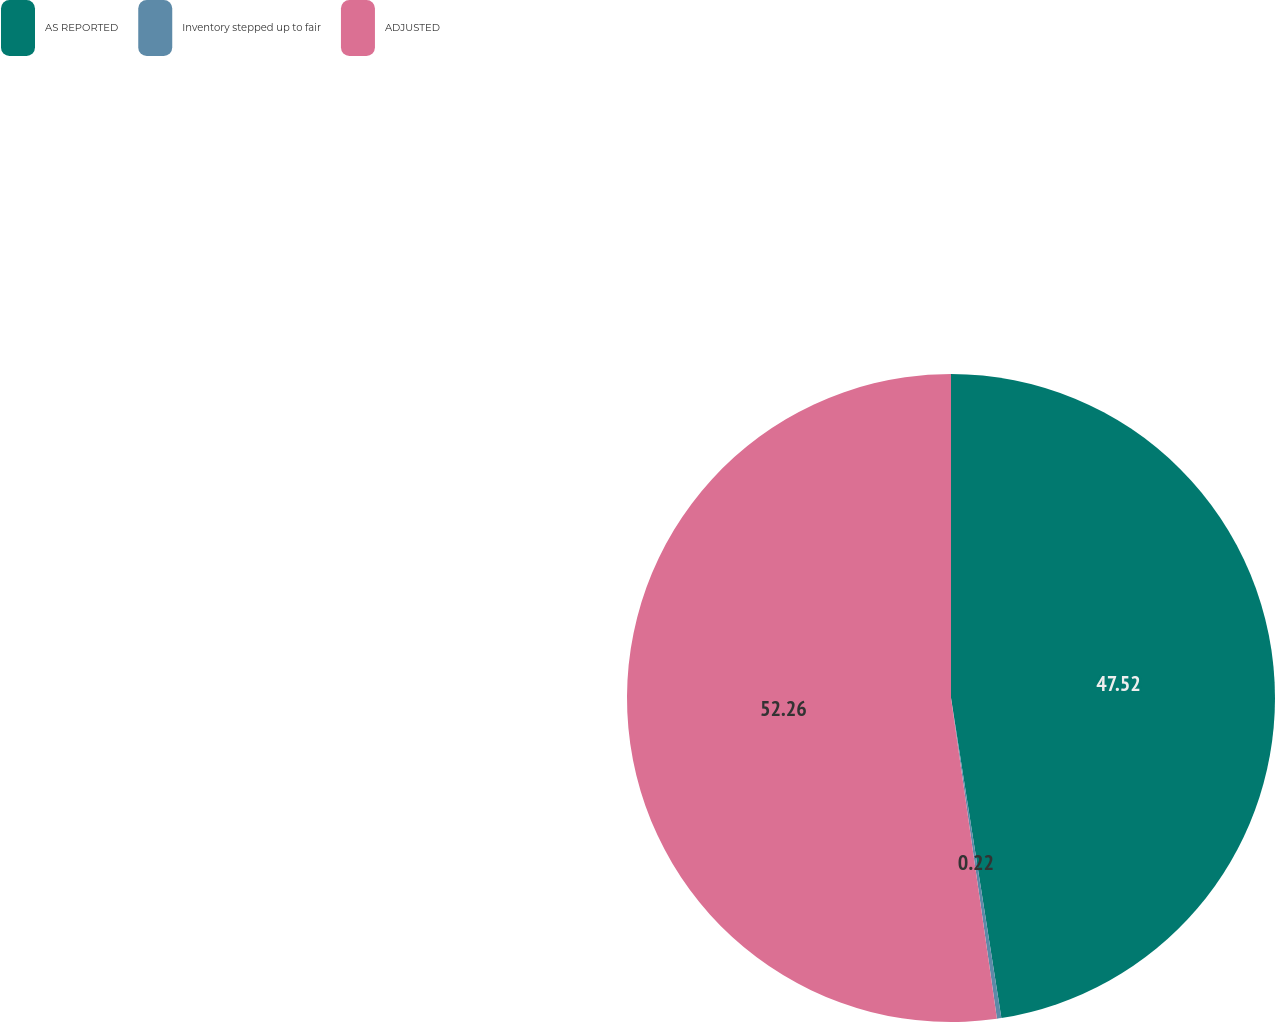<chart> <loc_0><loc_0><loc_500><loc_500><pie_chart><fcel>AS REPORTED<fcel>Inventory stepped up to fair<fcel>ADJUSTED<nl><fcel>47.52%<fcel>0.22%<fcel>52.27%<nl></chart> 